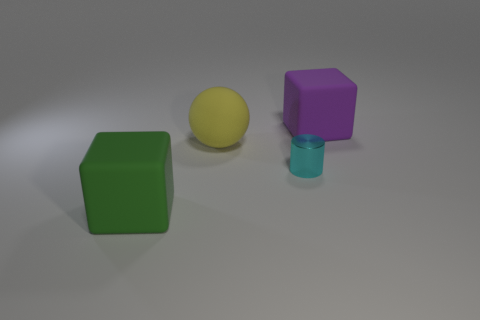Is there anything else that is made of the same material as the cylinder?
Give a very brief answer. No. What material is the big block that is in front of the rubber block right of the green matte block made of?
Give a very brief answer. Rubber. Is the number of yellow balls left of the big yellow matte object less than the number of metallic things?
Offer a terse response. Yes. There is a large green object that is the same material as the yellow object; what is its shape?
Keep it short and to the point. Cube. How many other objects are the same shape as the large yellow rubber thing?
Ensure brevity in your answer.  0. What number of green objects are small cylinders or large rubber balls?
Provide a succinct answer. 0. Is the shape of the green object the same as the big purple object?
Offer a very short reply. Yes. Are there any big things behind the large block that is right of the cylinder?
Provide a short and direct response. No. Are there the same number of big rubber objects that are to the right of the purple rubber block and big objects?
Your answer should be compact. No. What number of other objects are the same size as the green thing?
Provide a succinct answer. 2. 